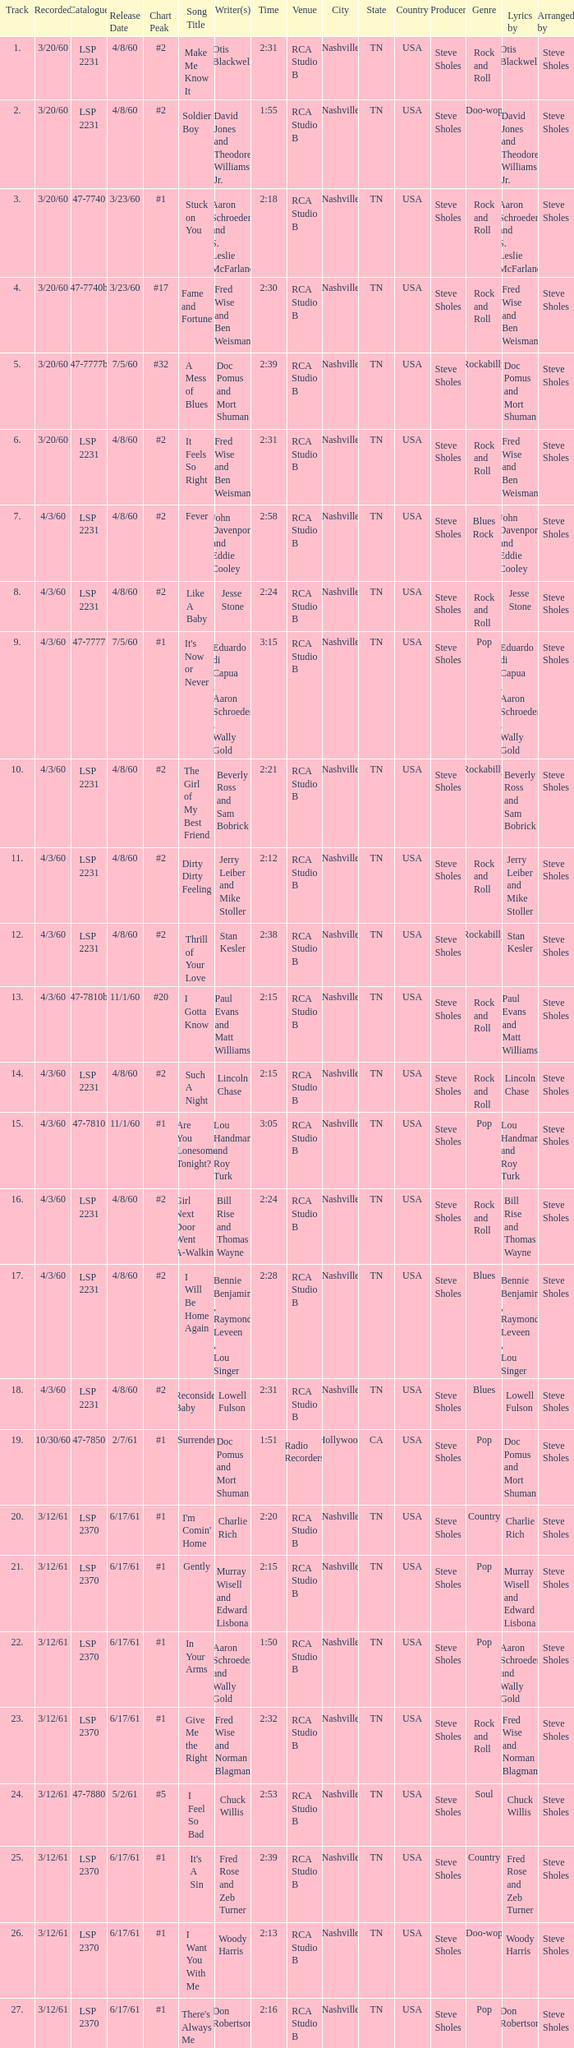On songs that have a release date of 6/17/61, a track larger than 20, and a writer of Woody Harris, what is the chart peak? #1. 